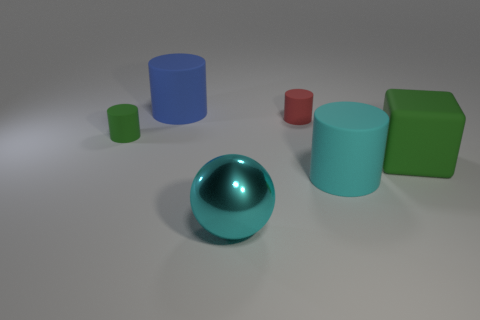Subtract all green matte cylinders. How many cylinders are left? 3 Add 1 small brown things. How many objects exist? 7 Subtract all cyan cylinders. How many cylinders are left? 3 Subtract 2 cylinders. How many cylinders are left? 2 Subtract all blue cylinders. How many red balls are left? 0 Add 6 large blue rubber things. How many large blue rubber things are left? 7 Add 6 green matte objects. How many green matte objects exist? 8 Subtract 1 cyan cylinders. How many objects are left? 5 Subtract all cylinders. How many objects are left? 2 Subtract all blue cylinders. Subtract all green blocks. How many cylinders are left? 3 